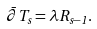<formula> <loc_0><loc_0><loc_500><loc_500>\bar { \partial } T _ { s } = \lambda R _ { s - 1 } .</formula> 